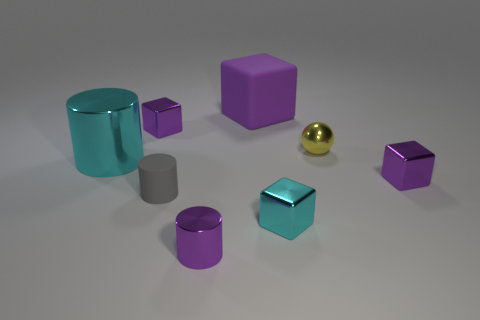The purple thing that is both on the left side of the purple rubber thing and behind the purple metal cylinder is made of what material?
Ensure brevity in your answer.  Metal. How many cyan metallic objects have the same size as the cyan block?
Your answer should be very brief. 0. There is another purple object that is the same shape as the large shiny object; what is it made of?
Provide a short and direct response. Metal. How many objects are things that are behind the large shiny object or tiny purple metal blocks in front of the big cyan shiny cylinder?
Give a very brief answer. 4. There is a large rubber thing; is it the same shape as the small purple shiny object that is on the right side of the tiny yellow metallic ball?
Ensure brevity in your answer.  Yes. There is a purple object that is in front of the purple metallic cube that is on the right side of the cyan object that is right of the large purple rubber thing; what is its shape?
Your answer should be compact. Cylinder. What number of other objects are the same material as the purple cylinder?
Your answer should be very brief. 5. What number of objects are either small blocks that are to the left of the yellow ball or cubes?
Keep it short and to the point. 4. The large thing to the right of the large cyan cylinder left of the tiny gray cylinder is what shape?
Your answer should be compact. Cube. There is a cyan metallic thing behind the gray thing; is it the same shape as the small gray rubber object?
Offer a very short reply. Yes. 